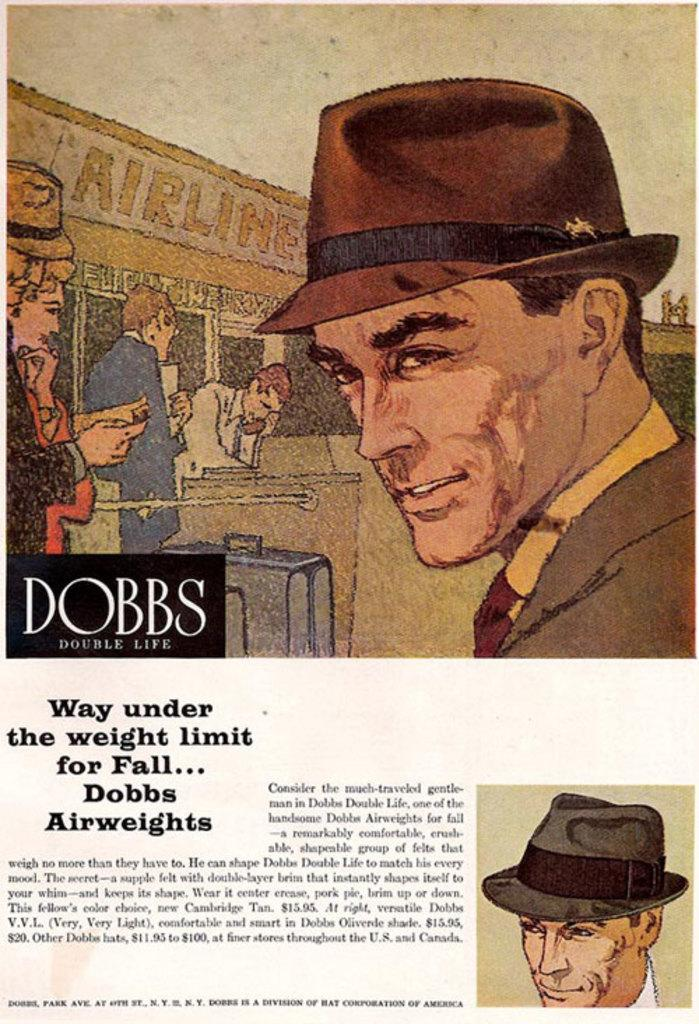What type of visual is the image? The image is a poster. What can be seen on the poster? There are pictures of persons on the poster. Is there any text on the poster? Yes, text is written on the poster. What type of advice can be seen on the poster? There is no advice present on the poster; it only contains pictures of persons and text. Is the poster framed in the image? The provided facts do not mention a frame, so it cannot be determined if the poster is framed or not. 